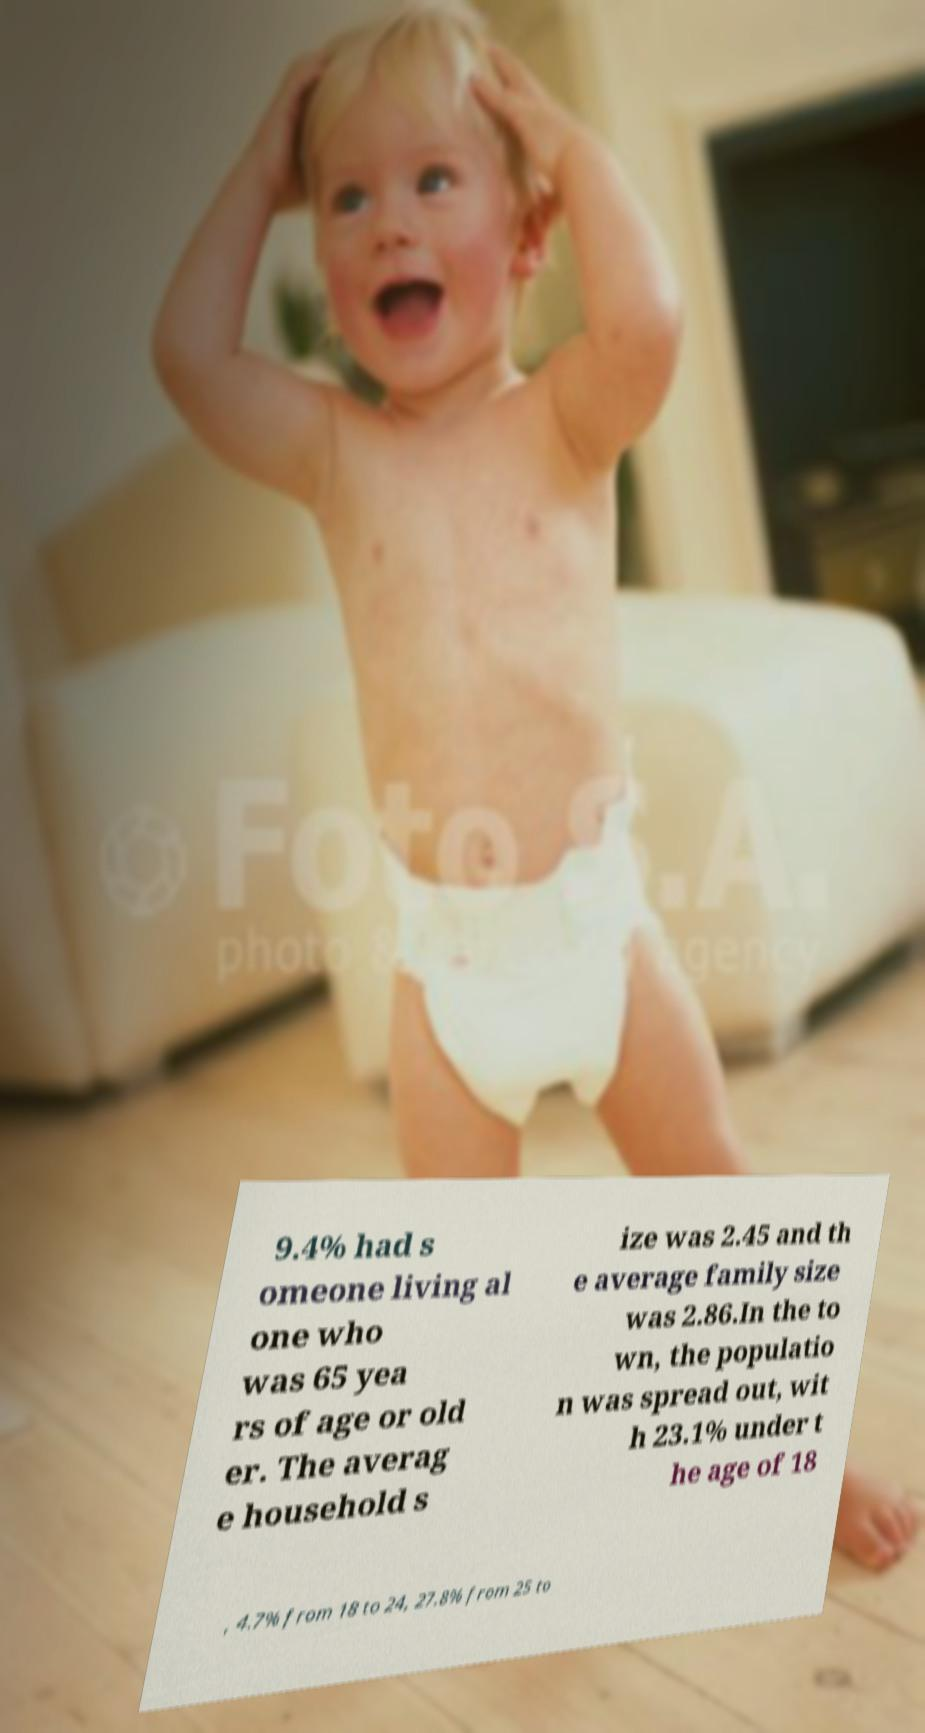Could you assist in decoding the text presented in this image and type it out clearly? 9.4% had s omeone living al one who was 65 yea rs of age or old er. The averag e household s ize was 2.45 and th e average family size was 2.86.In the to wn, the populatio n was spread out, wit h 23.1% under t he age of 18 , 4.7% from 18 to 24, 27.8% from 25 to 